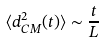Convert formula to latex. <formula><loc_0><loc_0><loc_500><loc_500>\langle d _ { C M } ^ { 2 } ( t ) \rangle \sim \frac { t } { L }</formula> 